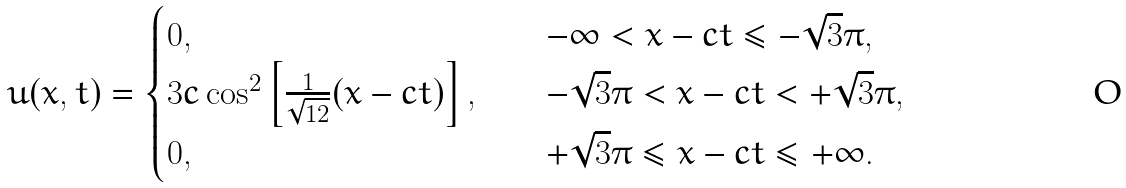<formula> <loc_0><loc_0><loc_500><loc_500>u ( x , t ) = \begin{cases} 0 , & \quad - \infty < x - c t \leq - \sqrt { 3 } \pi , \\ 3 c \cos ^ { 2 } \left [ \frac { 1 } { \sqrt { 1 2 } } ( x - c t ) \right ] , & \quad - \sqrt { 3 } \pi < x - c t < + \sqrt { 3 } \pi , \\ 0 , & \quad + \sqrt { 3 } \pi \leq x - c t \leq + \infty . \end{cases}</formula> 